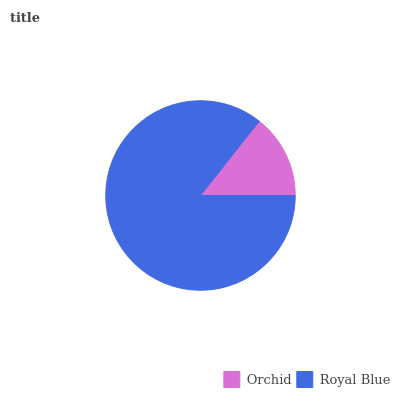Is Orchid the minimum?
Answer yes or no. Yes. Is Royal Blue the maximum?
Answer yes or no. Yes. Is Royal Blue the minimum?
Answer yes or no. No. Is Royal Blue greater than Orchid?
Answer yes or no. Yes. Is Orchid less than Royal Blue?
Answer yes or no. Yes. Is Orchid greater than Royal Blue?
Answer yes or no. No. Is Royal Blue less than Orchid?
Answer yes or no. No. Is Royal Blue the high median?
Answer yes or no. Yes. Is Orchid the low median?
Answer yes or no. Yes. Is Orchid the high median?
Answer yes or no. No. Is Royal Blue the low median?
Answer yes or no. No. 